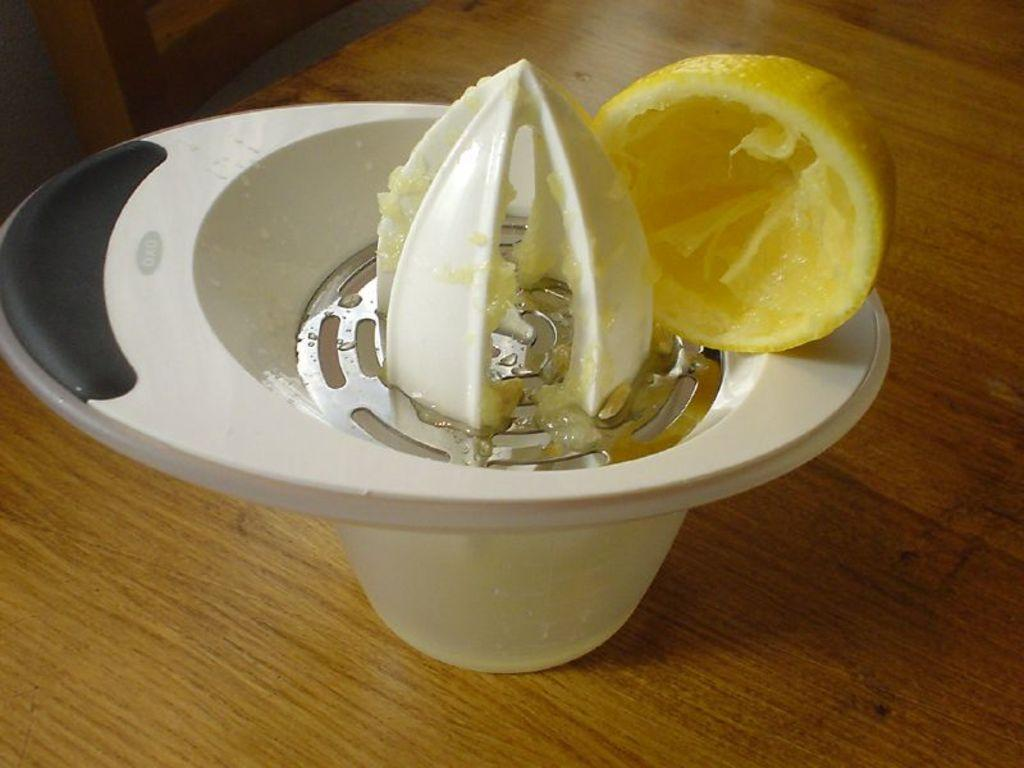What is the main object in the image? There is a juice squeezer in the image. What is on top of the juice squeezer? A lemon is on the juice squeezer. What type of surface is the juice squeezer placed on? The juice squeezer is placed on a wooden table. What type of fork can be seen in the image? There is no fork present in the image. How does the juice squeezer affect the acoustics of the room? The image does not provide information about the acoustics of the room, and the juice squeezer is not known to have any impact on acoustics. 